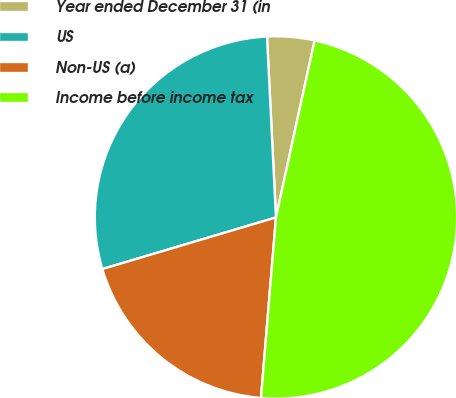Convert chart. <chart><loc_0><loc_0><loc_500><loc_500><pie_chart><fcel>Year ended December 31 (in<fcel>US<fcel>Non-US (a)<fcel>Income before income tax<nl><fcel>4.21%<fcel>28.81%<fcel>19.08%<fcel>47.89%<nl></chart> 